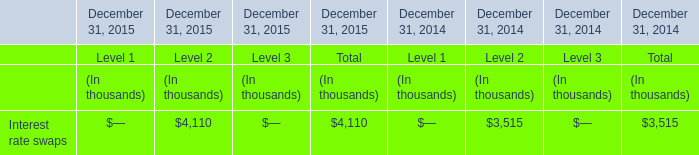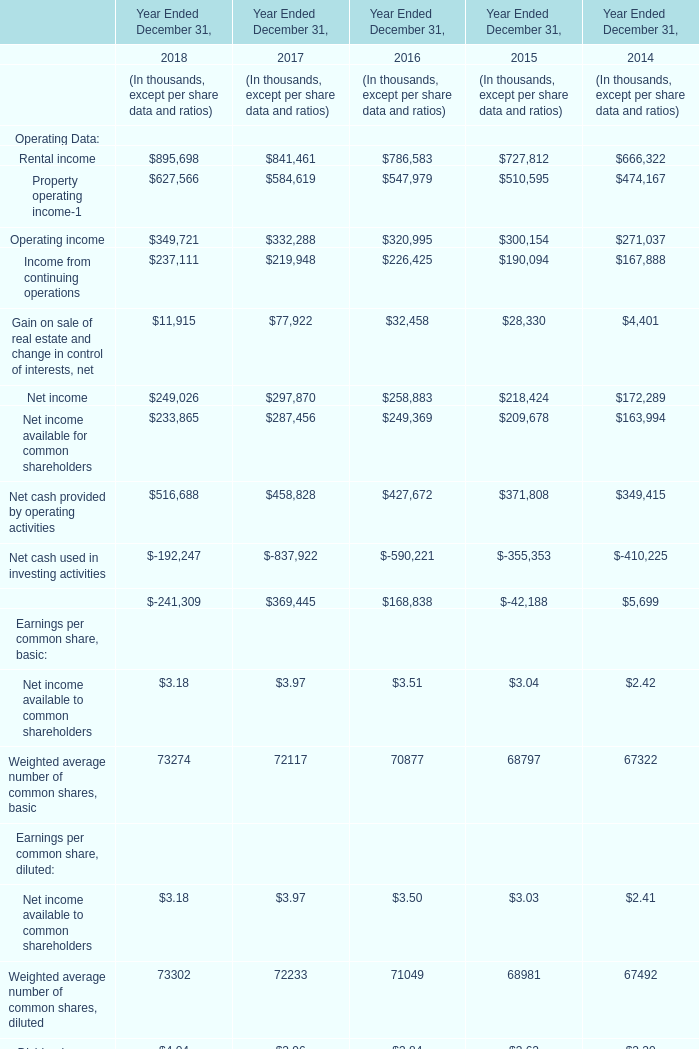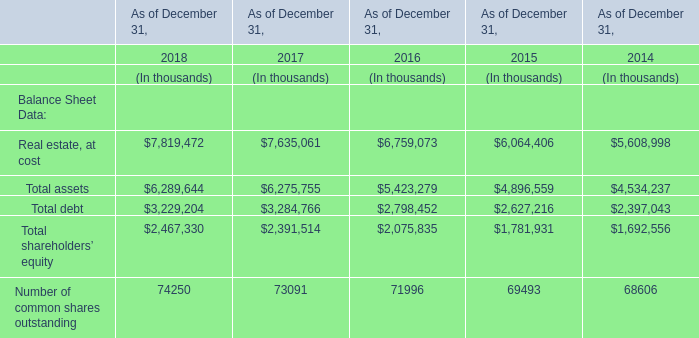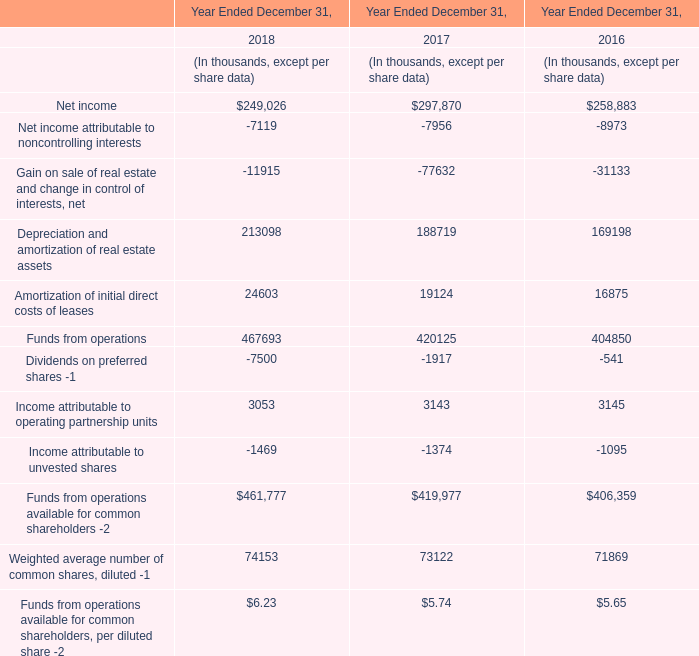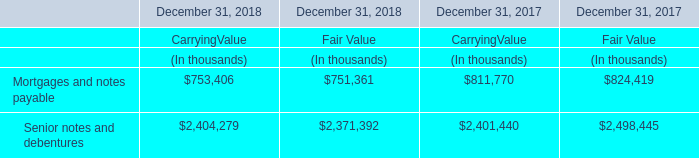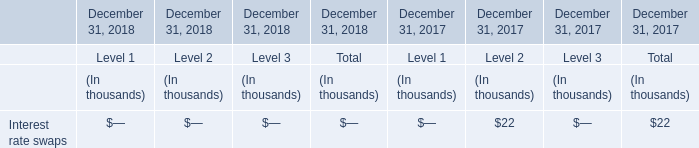If rental income develops with the same growth rate in 2018, what will it reach in 2019? (in thousand) 
Computations: ((((895698 - 841461) / 841461) + 1) * 895698)
Answer: 953430.88652. 